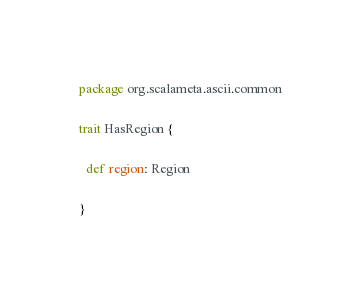<code> <loc_0><loc_0><loc_500><loc_500><_Scala_>package org.scalameta.ascii.common

trait HasRegion {

  def region: Region

}
</code> 